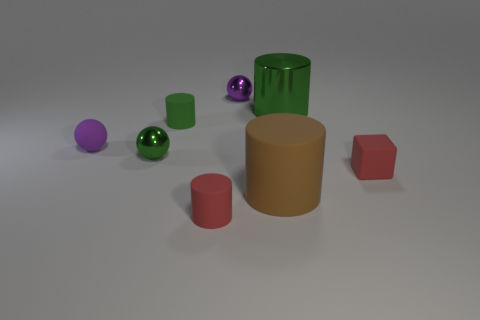Are there fewer small green spheres right of the small green ball than small red rubber cubes?
Your response must be concise. Yes. There is a rubber cylinder in front of the large brown object; what is its size?
Offer a terse response. Small. What is the color of the large metal thing that is the same shape as the brown rubber thing?
Give a very brief answer. Green. How many rubber cylinders are the same color as the small rubber ball?
Provide a short and direct response. 0. Is there any other thing that is the same shape as the large green shiny thing?
Make the answer very short. Yes. There is a shiny sphere that is to the right of the red matte object on the left side of the small red block; is there a metallic ball in front of it?
Make the answer very short. Yes. What number of other cylinders are made of the same material as the red cylinder?
Provide a succinct answer. 2. There is a red thing on the left side of the small red matte block; does it have the same size as the metal thing that is in front of the tiny green cylinder?
Your response must be concise. Yes. The large cylinder that is left of the green shiny thing that is to the right of the metallic ball in front of the large green cylinder is what color?
Ensure brevity in your answer.  Brown. Is there a brown metallic object of the same shape as the tiny green rubber object?
Provide a succinct answer. No. 